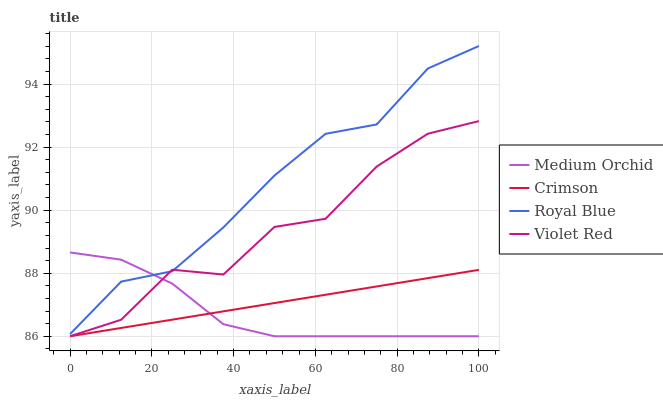Does Medium Orchid have the minimum area under the curve?
Answer yes or no. Yes. Does Royal Blue have the maximum area under the curve?
Answer yes or no. Yes. Does Violet Red have the minimum area under the curve?
Answer yes or no. No. Does Violet Red have the maximum area under the curve?
Answer yes or no. No. Is Crimson the smoothest?
Answer yes or no. Yes. Is Violet Red the roughest?
Answer yes or no. Yes. Is Royal Blue the smoothest?
Answer yes or no. No. Is Royal Blue the roughest?
Answer yes or no. No. Does Royal Blue have the lowest value?
Answer yes or no. No. Does Violet Red have the highest value?
Answer yes or no. No. Is Crimson less than Royal Blue?
Answer yes or no. Yes. Is Royal Blue greater than Crimson?
Answer yes or no. Yes. Does Crimson intersect Royal Blue?
Answer yes or no. No. 